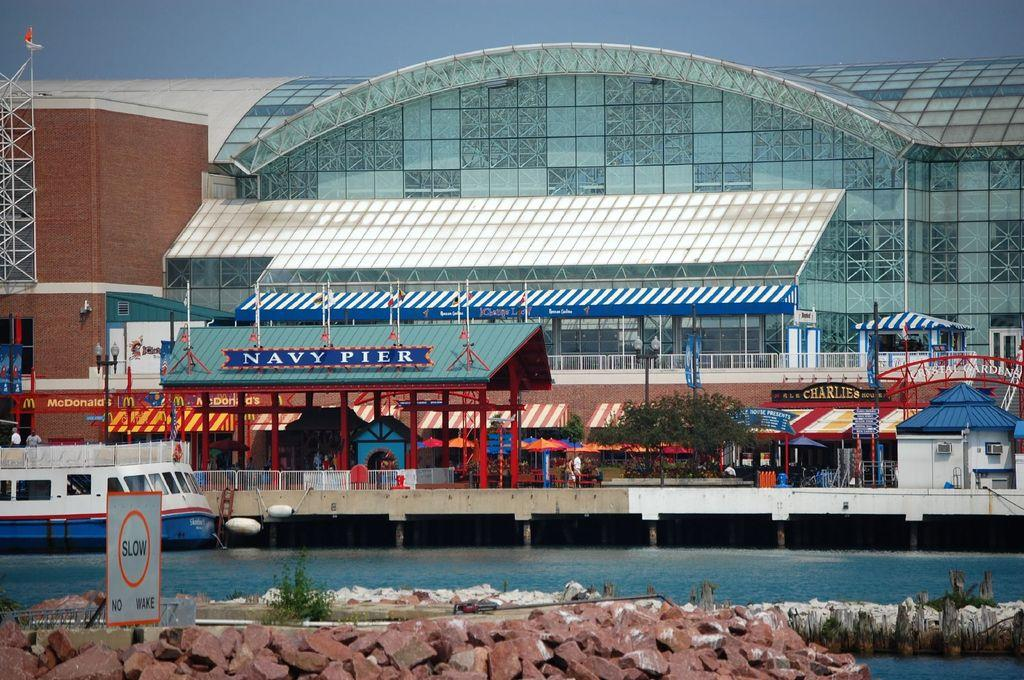What type of body of water is present in the image? There is a lake in the image. What is located in the lake? There is a boat in the lake. What can be seen in the background of the image? There is a shopping mall in the background of the image. What is visible at the top of the image? The sky is visible at the top of the image. How many cars are parked in the expansion of the shopping mall in the image? There is no mention of an expansion of the shopping mall or any cars in the image. 